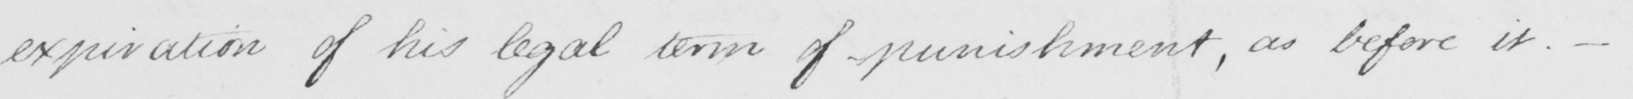Can you read and transcribe this handwriting? expiration of his legal terms of punishment , as before it . _ 